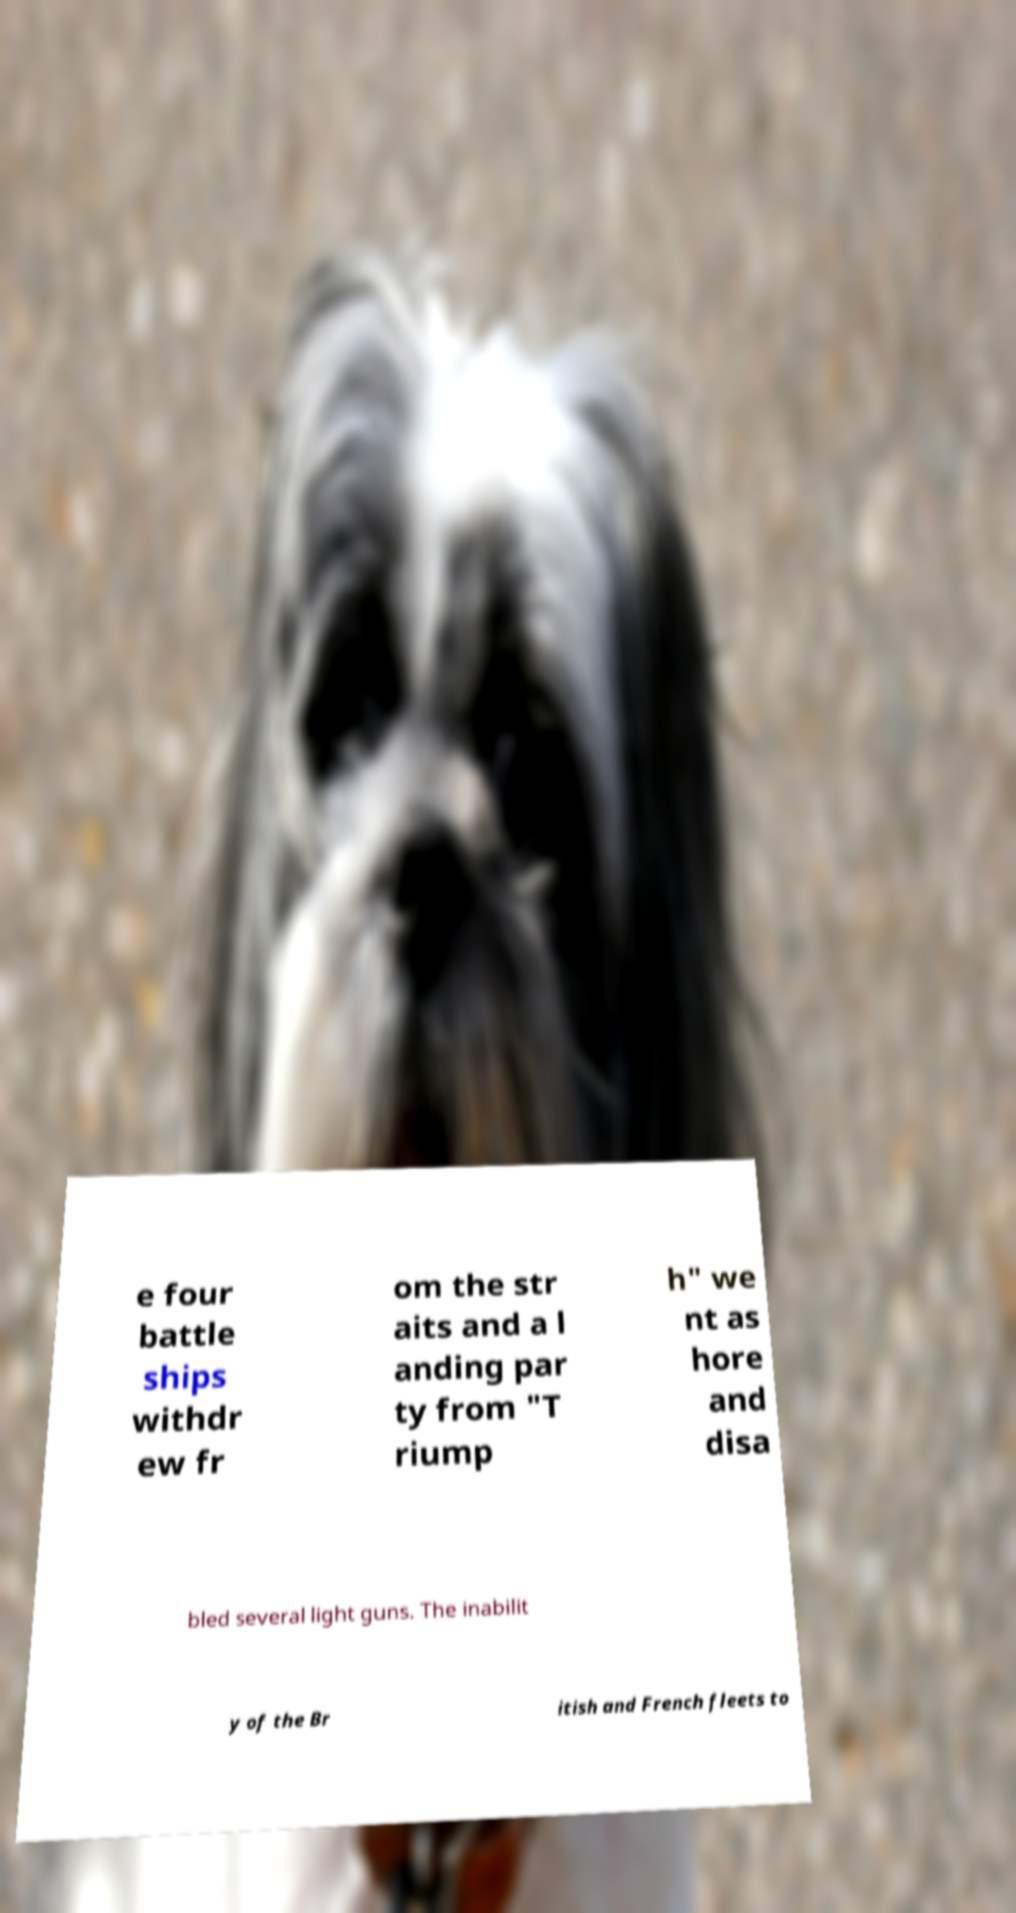Can you read and provide the text displayed in the image?This photo seems to have some interesting text. Can you extract and type it out for me? e four battle ships withdr ew fr om the str aits and a l anding par ty from "T riump h" we nt as hore and disa bled several light guns. The inabilit y of the Br itish and French fleets to 